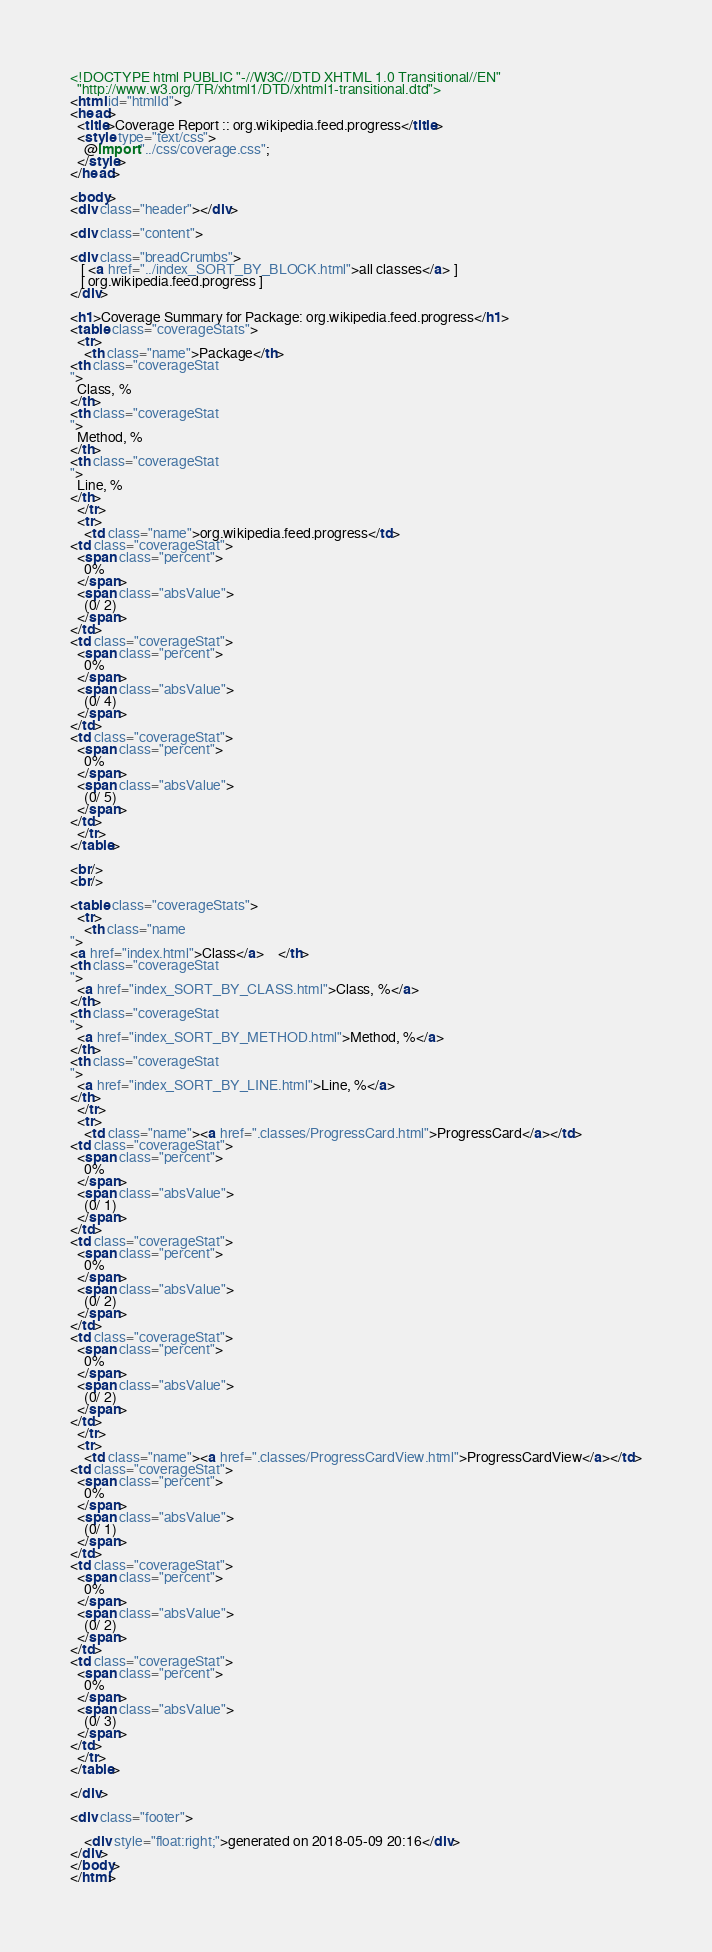Convert code to text. <code><loc_0><loc_0><loc_500><loc_500><_HTML_>
<!DOCTYPE html PUBLIC "-//W3C//DTD XHTML 1.0 Transitional//EN"
  "http://www.w3.org/TR/xhtml1/DTD/xhtml1-transitional.dtd">
<html id="htmlId">
<head>
  <title>Coverage Report :: org.wikipedia.feed.progress</title>
  <style type="text/css">
    @import "../css/coverage.css";
  </style>
</head>

<body>
<div class="header"></div>

<div class="content">

<div class="breadCrumbs">
   [ <a href="../index_SORT_BY_BLOCK.html">all classes</a> ]
   [ org.wikipedia.feed.progress ]
</div>

<h1>Coverage Summary for Package: org.wikipedia.feed.progress</h1>
<table class="coverageStats">
  <tr>
    <th class="name">Package</th>
<th class="coverageStat 
">
  Class, %
</th>
<th class="coverageStat 
">
  Method, %
</th>
<th class="coverageStat 
">
  Line, %
</th>
  </tr>
  <tr>
    <td class="name">org.wikipedia.feed.progress</td>
<td class="coverageStat">
  <span class="percent">
    0%
  </span>
  <span class="absValue">
    (0/ 2)
  </span>
</td>
<td class="coverageStat">
  <span class="percent">
    0%
  </span>
  <span class="absValue">
    (0/ 4)
  </span>
</td>
<td class="coverageStat">
  <span class="percent">
    0%
  </span>
  <span class="absValue">
    (0/ 5)
  </span>
</td>
  </tr>
</table>

<br/>
<br/>

<table class="coverageStats">
  <tr>
    <th class="name  
">
<a href="index.html">Class</a>    </th>
<th class="coverageStat 
">
  <a href="index_SORT_BY_CLASS.html">Class, %</a>
</th>
<th class="coverageStat 
">
  <a href="index_SORT_BY_METHOD.html">Method, %</a>
</th>
<th class="coverageStat 
">
  <a href="index_SORT_BY_LINE.html">Line, %</a>
</th>
  </tr>
  <tr>
    <td class="name"><a href=".classes/ProgressCard.html">ProgressCard</a></td>
<td class="coverageStat">
  <span class="percent">
    0%
  </span>
  <span class="absValue">
    (0/ 1)
  </span>
</td>
<td class="coverageStat">
  <span class="percent">
    0%
  </span>
  <span class="absValue">
    (0/ 2)
  </span>
</td>
<td class="coverageStat">
  <span class="percent">
    0%
  </span>
  <span class="absValue">
    (0/ 2)
  </span>
</td>
  </tr>
  <tr>
    <td class="name"><a href=".classes/ProgressCardView.html">ProgressCardView</a></td>
<td class="coverageStat">
  <span class="percent">
    0%
  </span>
  <span class="absValue">
    (0/ 1)
  </span>
</td>
<td class="coverageStat">
  <span class="percent">
    0%
  </span>
  <span class="absValue">
    (0/ 2)
  </span>
</td>
<td class="coverageStat">
  <span class="percent">
    0%
  </span>
  <span class="absValue">
    (0/ 3)
  </span>
</td>
  </tr>
</table>

</div>

<div class="footer">
    
    <div style="float:right;">generated on 2018-05-09 20:16</div>
</div>
</body>
</html>
</code> 